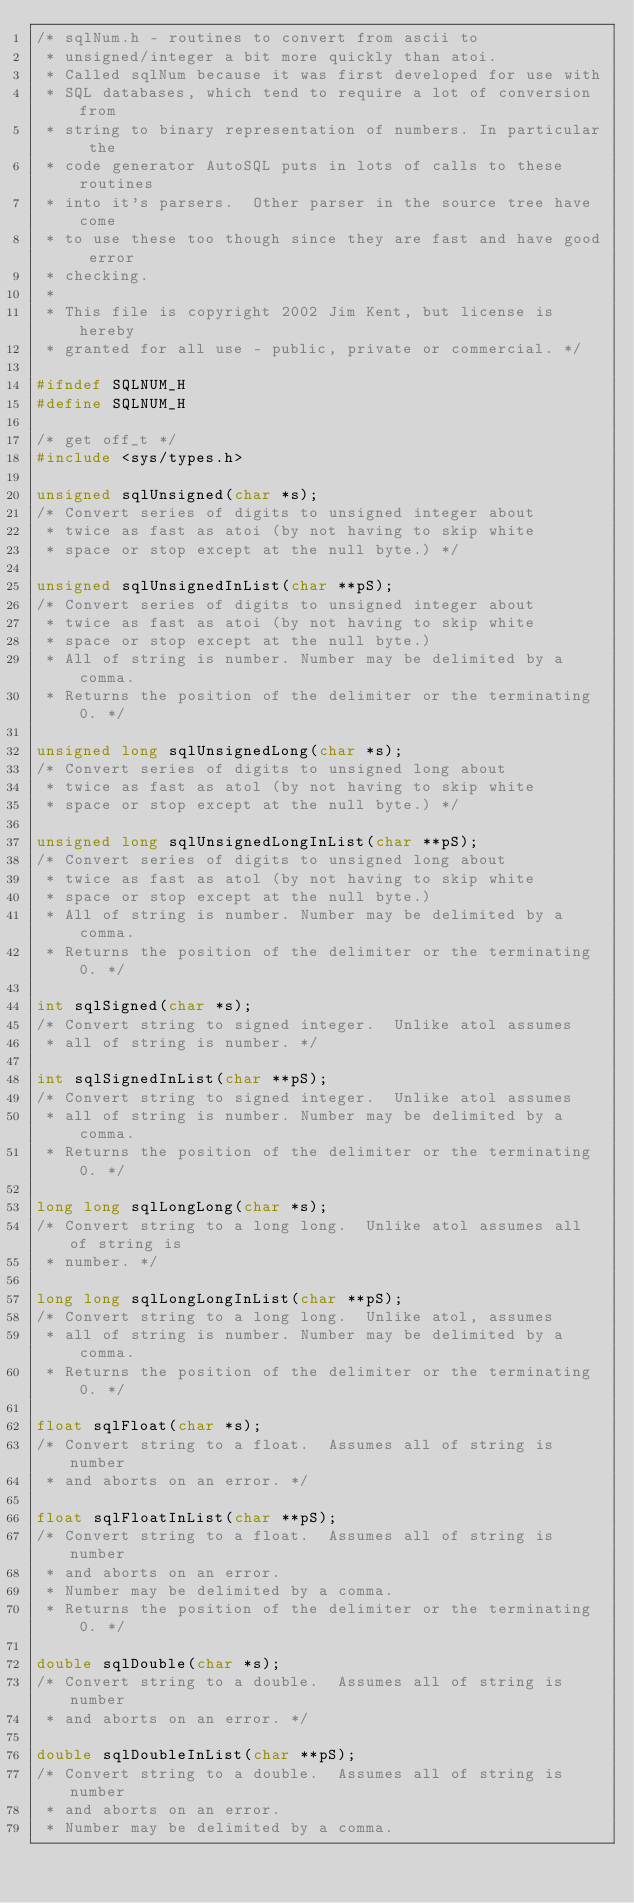<code> <loc_0><loc_0><loc_500><loc_500><_C_>/* sqlNum.h - routines to convert from ascii to
 * unsigned/integer a bit more quickly than atoi. 
 * Called sqlNum because it was first developed for use with
 * SQL databases, which tend to require a lot of conversion from
 * string to binary representation of numbers. In particular the
 * code generator AutoSQL puts in lots of calls to these routines
 * into it's parsers.  Other parser in the source tree have come
 * to use these too though since they are fast and have good error
 * checking.
 *
 * This file is copyright 2002 Jim Kent, but license is hereby
 * granted for all use - public, private or commercial. */

#ifndef SQLNUM_H
#define SQLNUM_H

/* get off_t */
#include <sys/types.h>

unsigned sqlUnsigned(char *s);
/* Convert series of digits to unsigned integer about
 * twice as fast as atoi (by not having to skip white 
 * space or stop except at the null byte.) */

unsigned sqlUnsignedInList(char **pS);
/* Convert series of digits to unsigned integer about
 * twice as fast as atoi (by not having to skip white 
 * space or stop except at the null byte.) 
 * All of string is number. Number may be delimited by a comma. 
 * Returns the position of the delimiter or the terminating 0. */

unsigned long sqlUnsignedLong(char *s);
/* Convert series of digits to unsigned long about
 * twice as fast as atol (by not having to skip white 
 * space or stop except at the null byte.) */

unsigned long sqlUnsignedLongInList(char **pS);
/* Convert series of digits to unsigned long about
 * twice as fast as atol (by not having to skip white 
 * space or stop except at the null byte.) 
 * All of string is number. Number may be delimited by a comma. 
 * Returns the position of the delimiter or the terminating 0. */

int sqlSigned(char *s);
/* Convert string to signed integer.  Unlike atol assumes 
 * all of string is number. */

int sqlSignedInList(char **pS);
/* Convert string to signed integer.  Unlike atol assumes 
 * all of string is number. Number may be delimited by a comma. 
 * Returns the position of the delimiter or the terminating 0. */

long long sqlLongLong(char *s);
/* Convert string to a long long.  Unlike atol assumes all of string is
 * number. */

long long sqlLongLongInList(char **pS);
/* Convert string to a long long.  Unlike atol, assumes 
 * all of string is number. Number may be delimited by a comma. 
 * Returns the position of the delimiter or the terminating 0. */

float sqlFloat(char *s);
/* Convert string to a float.  Assumes all of string is number
 * and aborts on an error. */

float sqlFloatInList(char **pS);
/* Convert string to a float.  Assumes all of string is number
 * and aborts on an error. 
 * Number may be delimited by a comma. 
 * Returns the position of the delimiter or the terminating 0. */

double sqlDouble(char *s);
/* Convert string to a double.  Assumes all of string is number
 * and aborts on an error. */

double sqlDoubleInList(char **pS);
/* Convert string to a double.  Assumes all of string is number
 * and aborts on an error.
 * Number may be delimited by a comma.</code> 